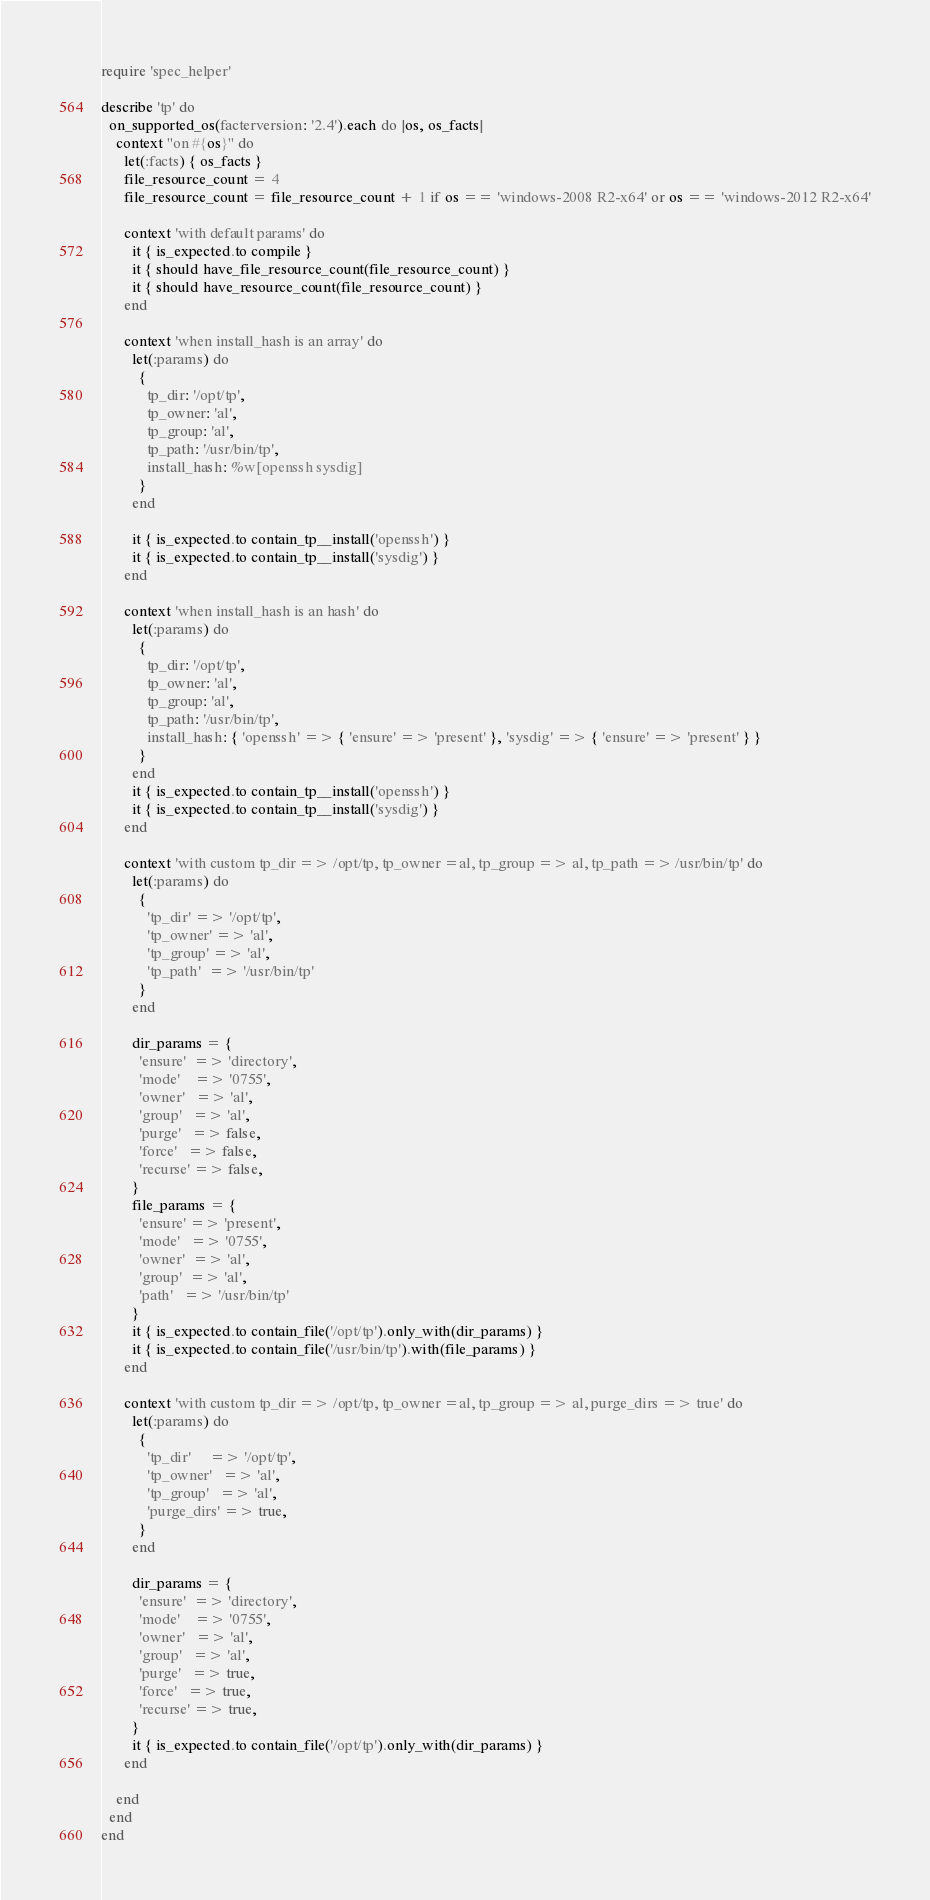Convert code to text. <code><loc_0><loc_0><loc_500><loc_500><_Ruby_>require 'spec_helper'

describe 'tp' do
  on_supported_os(facterversion: '2.4').each do |os, os_facts|
    context "on #{os}" do
      let(:facts) { os_facts }
      file_resource_count = 4
      file_resource_count = file_resource_count + 1 if os == 'windows-2008 R2-x64' or os == 'windows-2012 R2-x64'

      context 'with default params' do
        it { is_expected.to compile }
        it { should have_file_resource_count(file_resource_count) }
        it { should have_resource_count(file_resource_count) }
      end

      context 'when install_hash is an array' do
        let(:params) do
          {
            tp_dir: '/opt/tp',
            tp_owner: 'al',
            tp_group: 'al',
            tp_path: '/usr/bin/tp',
            install_hash: %w[openssh sysdig]
          }
        end

        it { is_expected.to contain_tp__install('openssh') }
        it { is_expected.to contain_tp__install('sysdig') }
      end

      context 'when install_hash is an hash' do
        let(:params) do
          {
            tp_dir: '/opt/tp',
            tp_owner: 'al',
            tp_group: 'al',
            tp_path: '/usr/bin/tp',
            install_hash: { 'openssh' => { 'ensure' => 'present' }, 'sysdig' => { 'ensure' => 'present' } }
          }
        end
        it { is_expected.to contain_tp__install('openssh') }
        it { is_expected.to contain_tp__install('sysdig') }
      end

      context 'with custom tp_dir => /opt/tp, tp_owner =al, tp_group => al, tp_path => /usr/bin/tp' do
        let(:params) do
          {
            'tp_dir' => '/opt/tp',
            'tp_owner' => 'al',
            'tp_group' => 'al',
            'tp_path'  => '/usr/bin/tp'
          }
        end

        dir_params = {
          'ensure'  => 'directory',
          'mode'    => '0755',
          'owner'   => 'al',
          'group'   => 'al',
          'purge'   => false,
          'force'   => false,
          'recurse' => false,
        }
        file_params = {
          'ensure' => 'present',
          'mode'   => '0755',
          'owner'  => 'al',
          'group'  => 'al',
          'path'   => '/usr/bin/tp'
        }
        it { is_expected.to contain_file('/opt/tp').only_with(dir_params) }
        it { is_expected.to contain_file('/usr/bin/tp').with(file_params) }
      end

      context 'with custom tp_dir => /opt/tp, tp_owner =al, tp_group => al, purge_dirs => true' do
        let(:params) do
          {
            'tp_dir'     => '/opt/tp',
            'tp_owner'   => 'al',
            'tp_group'   => 'al',
            'purge_dirs' => true,
          } 
        end
        
        dir_params = {
          'ensure'  => 'directory',
          'mode'    => '0755',
          'owner'   => 'al',
          'group'   => 'al',
          'purge'   => true,
          'force'   => true,
          'recurse' => true,
        } 
        it { is_expected.to contain_file('/opt/tp').only_with(dir_params) }
      end

    end
  end
end
</code> 